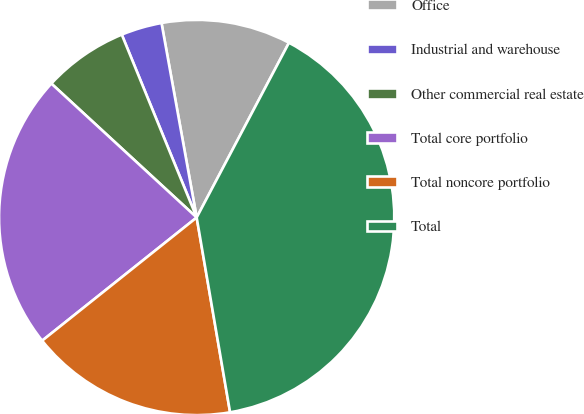Convert chart. <chart><loc_0><loc_0><loc_500><loc_500><pie_chart><fcel>Office<fcel>Industrial and warehouse<fcel>Other commercial real estate<fcel>Total core portfolio<fcel>Total noncore portfolio<fcel>Total<nl><fcel>10.58%<fcel>3.34%<fcel>6.96%<fcel>22.56%<fcel>16.99%<fcel>39.56%<nl></chart> 